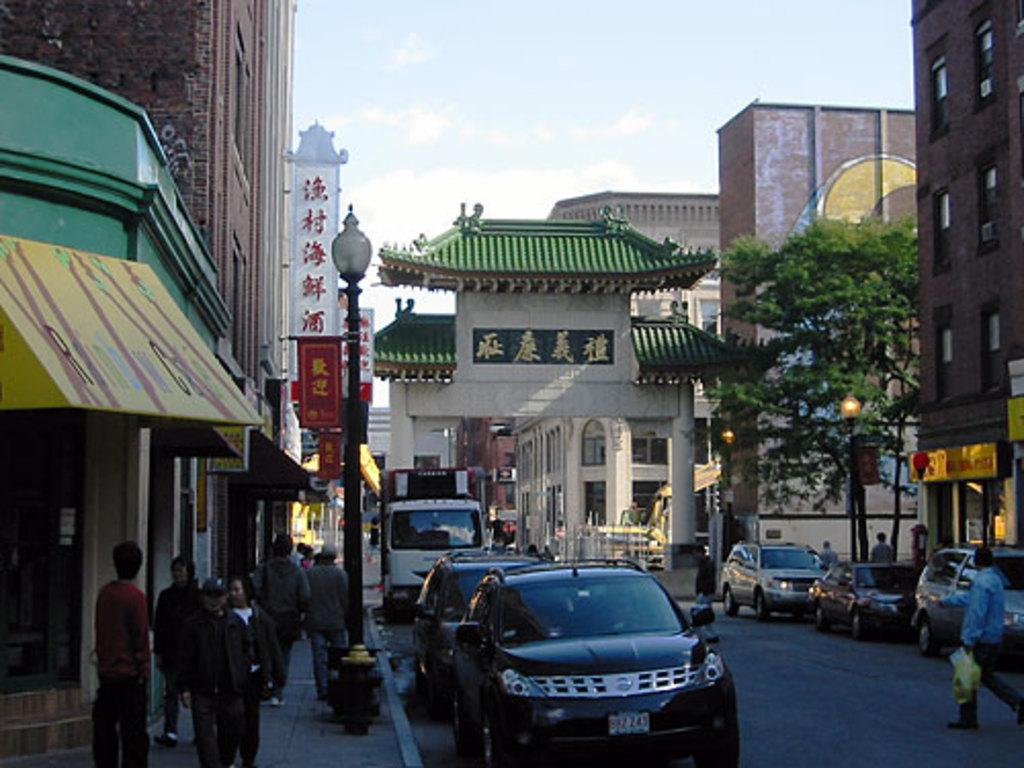What can be seen moving on the road in the image? There are vehicles on the road in the image. What can be seen on the walkway in the image? There are people on the walkway in the image. What structures are present in the image that support objects like wires or signs? There are poles in the image. What type of vegetation is visible in the image? There are trees in the image. What type of structures can be seen on either side of the road in the image? There are buildings on either side of the road in the image. What substance is being used to measure the head size of the person on the walkway? There is no indication in the image of any substance being used to measure head size. What month is it in the image? The image does not provide any information about the month or time of year. 